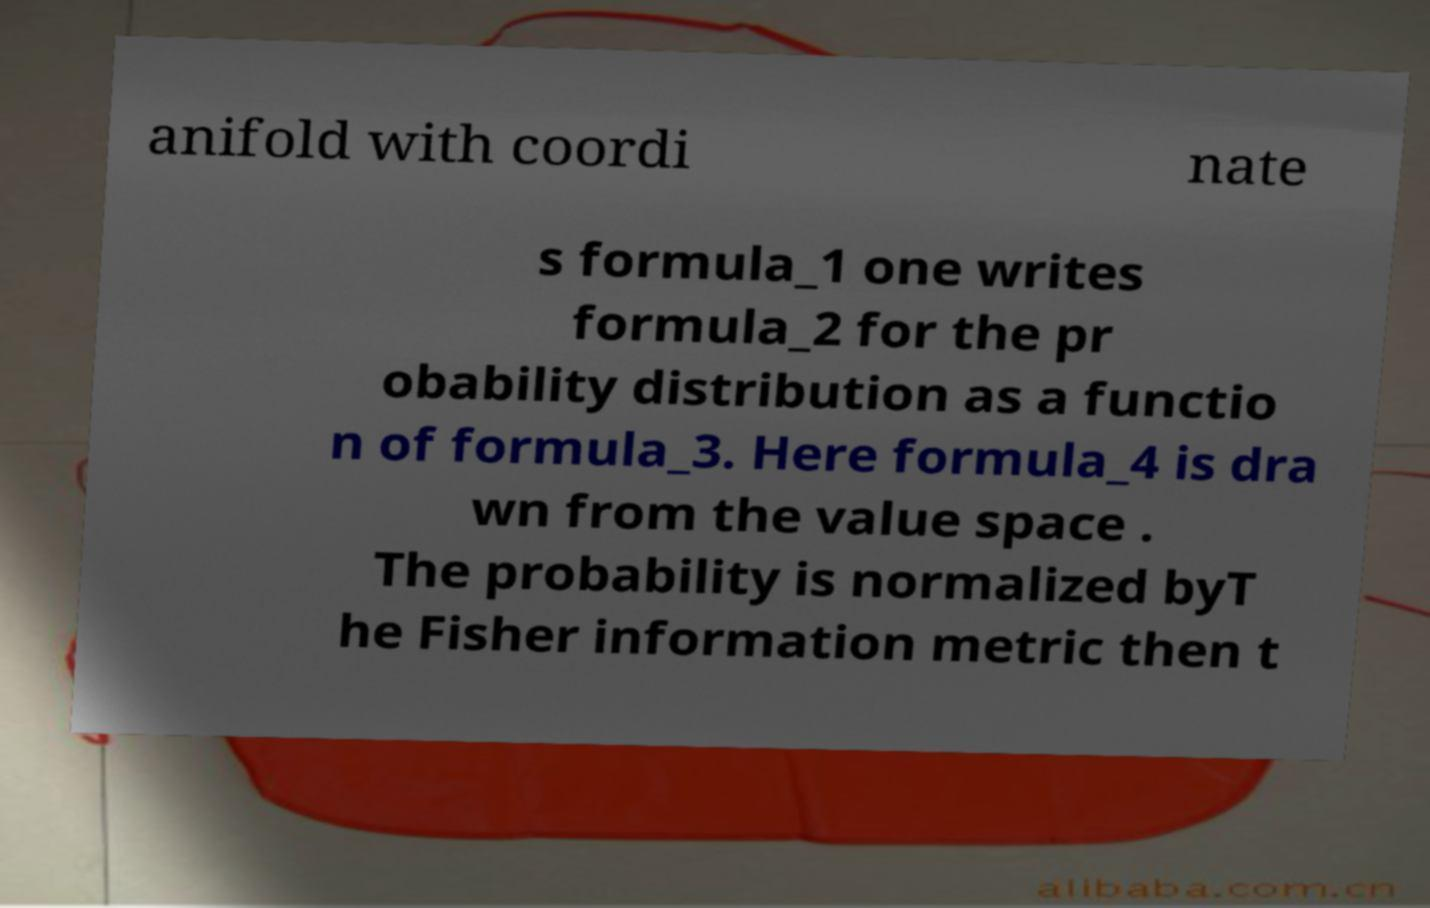For documentation purposes, I need the text within this image transcribed. Could you provide that? anifold with coordi nate s formula_1 one writes formula_2 for the pr obability distribution as a functio n of formula_3. Here formula_4 is dra wn from the value space . The probability is normalized byT he Fisher information metric then t 